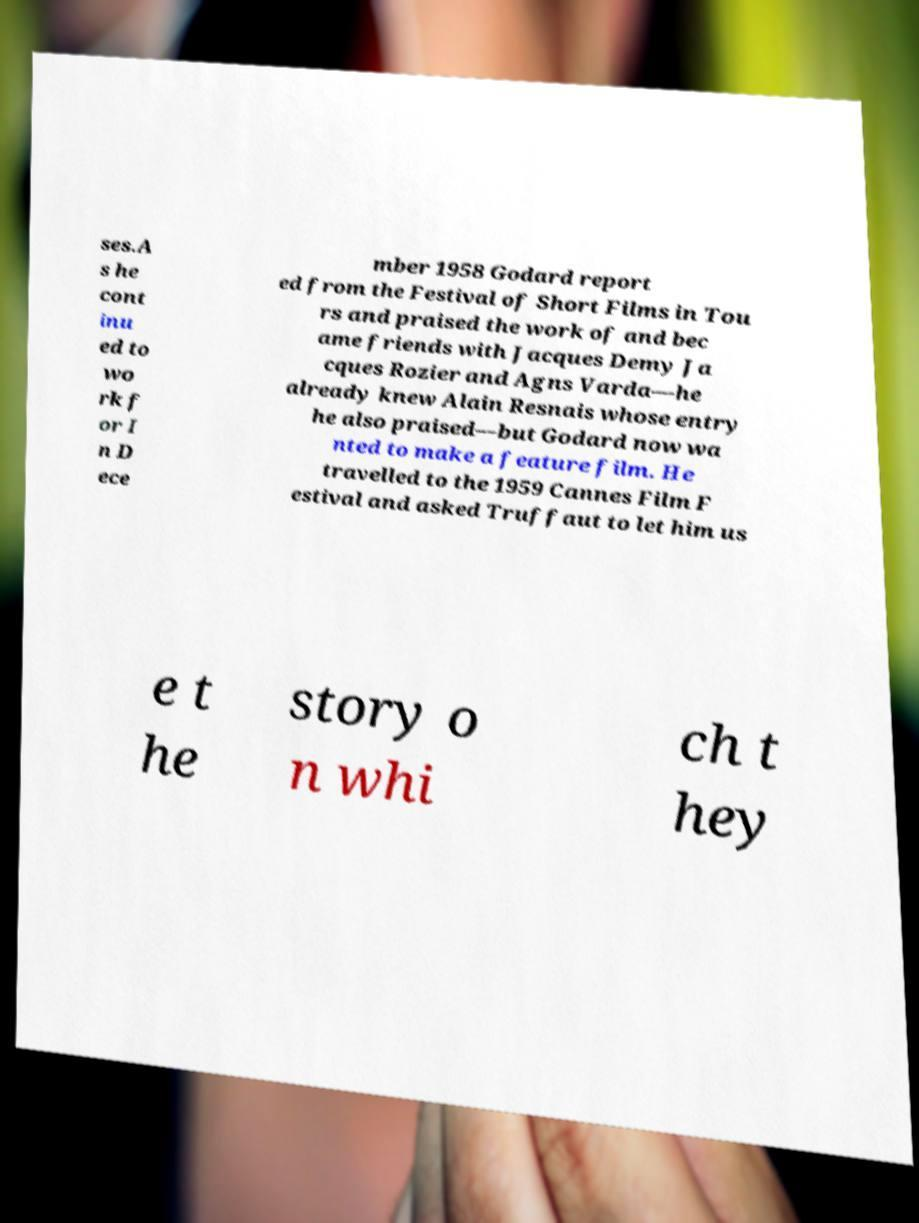What messages or text are displayed in this image? I need them in a readable, typed format. ses.A s he cont inu ed to wo rk f or I n D ece mber 1958 Godard report ed from the Festival of Short Films in Tou rs and praised the work of and bec ame friends with Jacques Demy Ja cques Rozier and Agns Varda—he already knew Alain Resnais whose entry he also praised—but Godard now wa nted to make a feature film. He travelled to the 1959 Cannes Film F estival and asked Truffaut to let him us e t he story o n whi ch t hey 